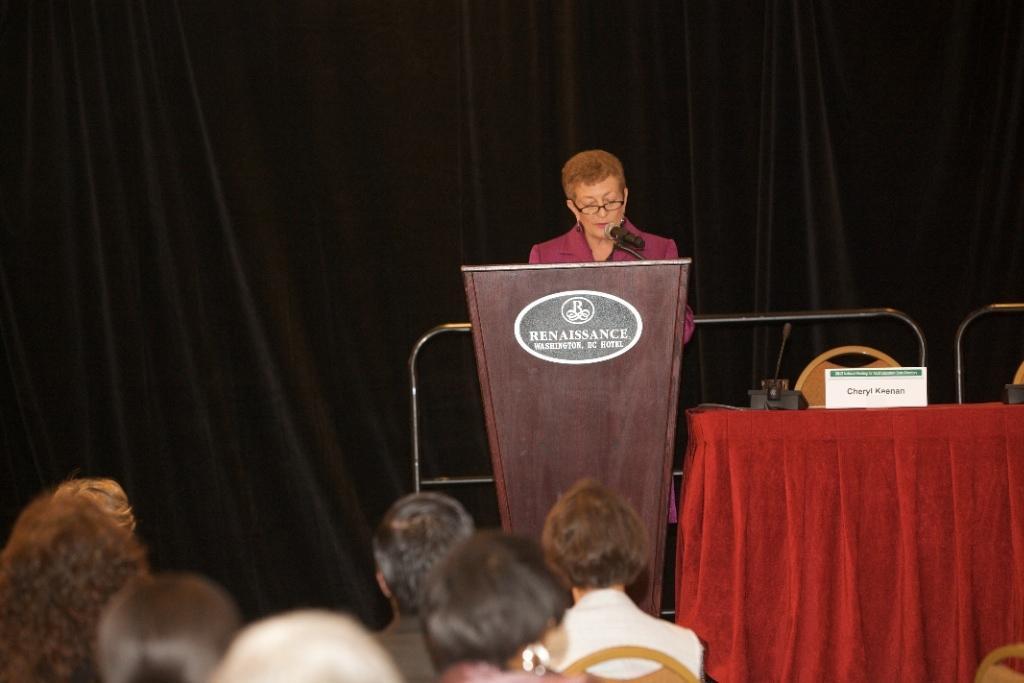Describe this image in one or two sentences. At the bottom there are few people sitting on a chairs facing towards the back side. In the background there is a person standing in front of the podium and speaking on the mike. On the right side there is a table which is covered with a red color cloth. On the table there is a name board and a microphone. Behind the table there is a chair. In the background there is a black color curtain and also I can see two metal rods. 